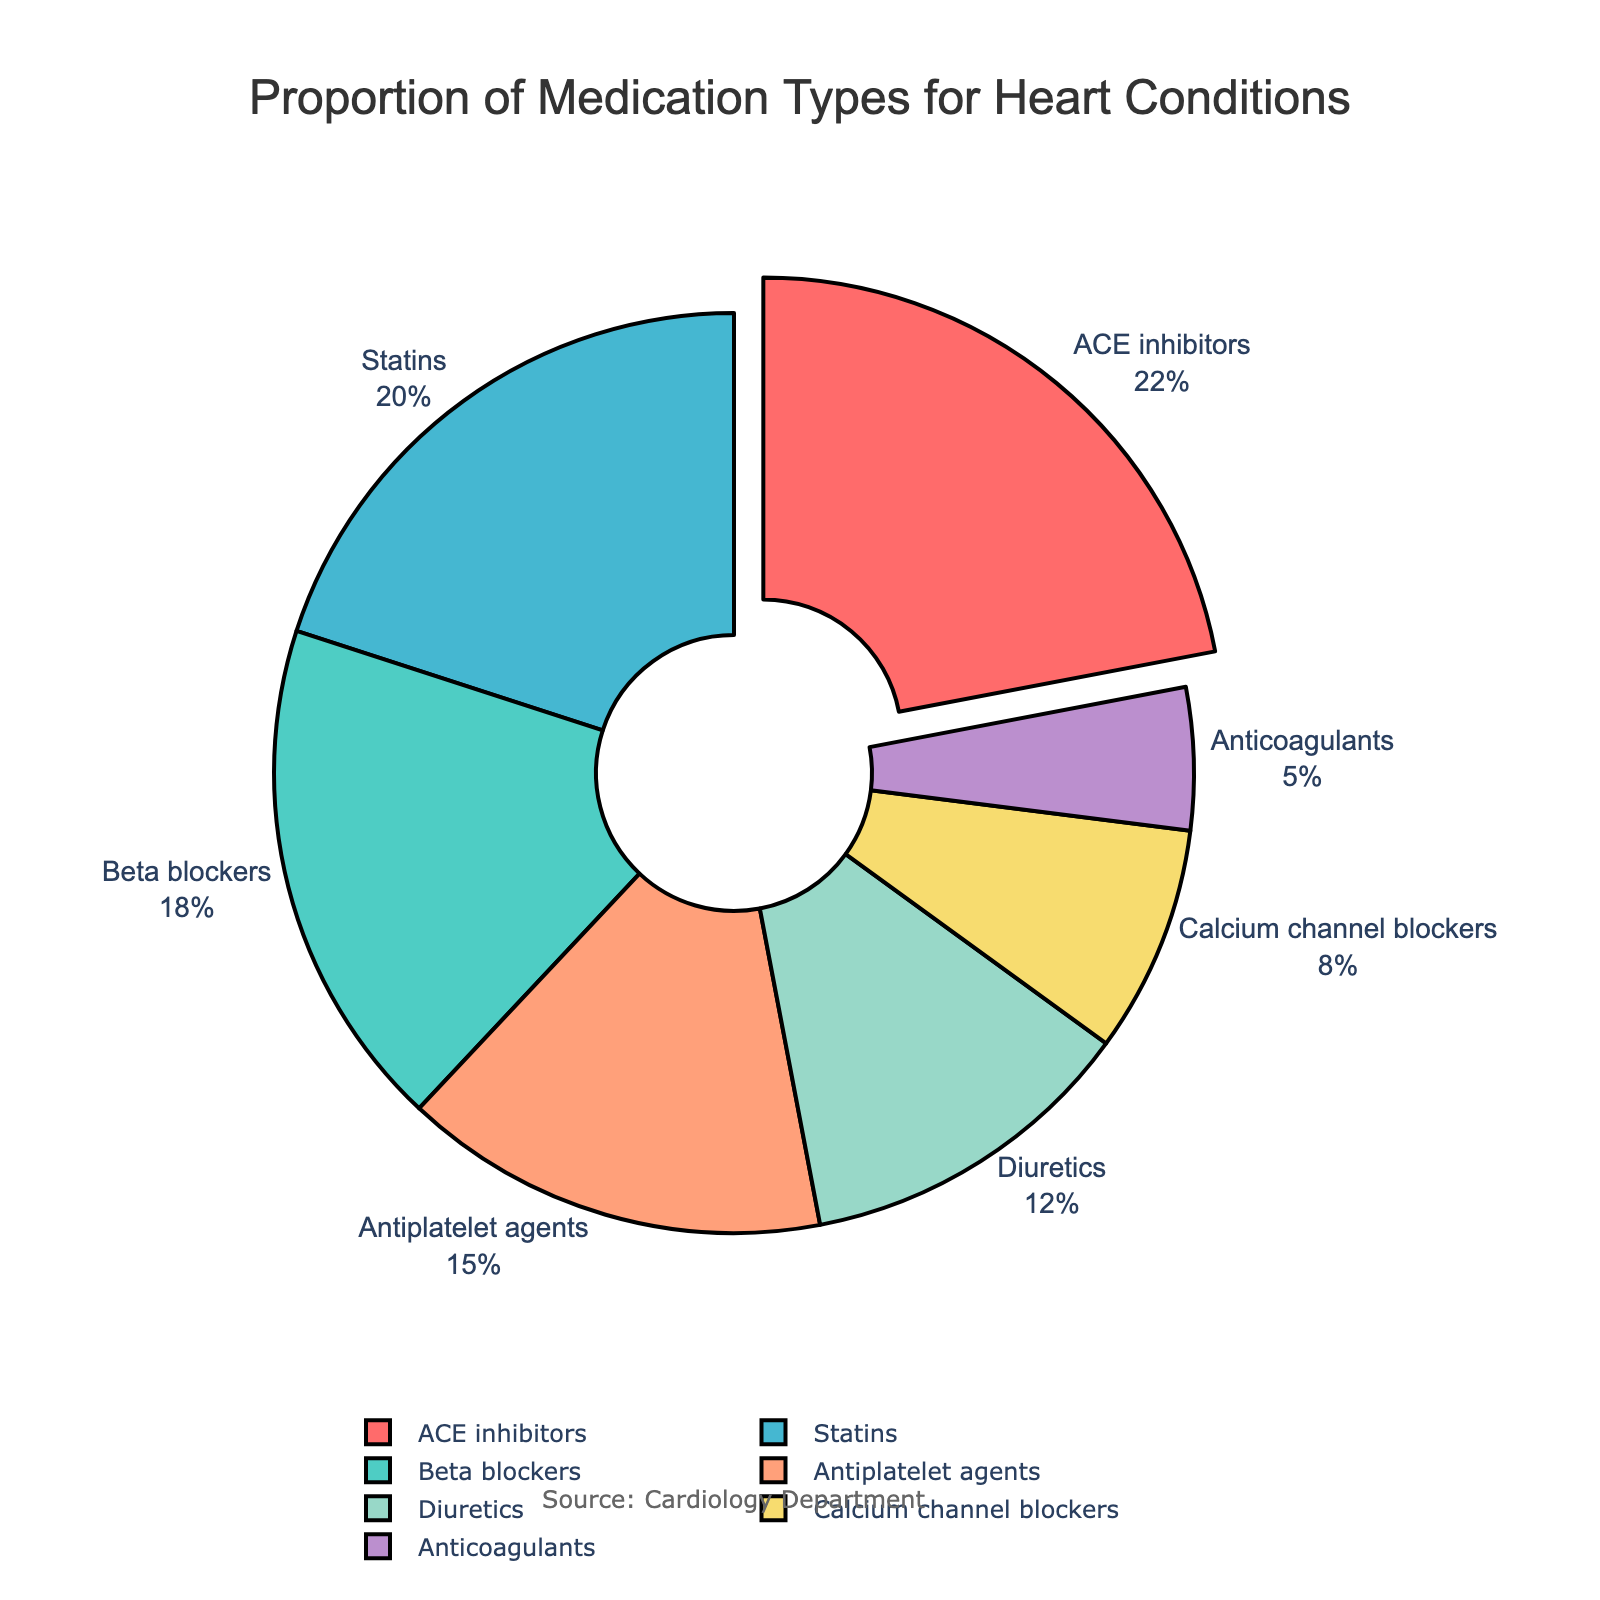What is the most frequently prescribed medication type for heart conditions according to the chart? Looking at the figure, identify the medication type with the largest percentage. This medication type also has a slice pulled out from the pie chart, indicating it is the major component. The largest segment is labeled "ACE inhibitors," which has the highest value of 22%.
Answer: ACE inhibitors What are the two least frequently prescribed medication types and their combined percentage? Identify the two medication types with the smallest percentages: "Anticoagulants" (5%) and "Calcium channel blockers" (8%). Add these percentages together: 5% + 8% = 13%.
Answer: Anticoagulants and Calcium channel blockers, 13% How much more frequently are ACE inhibitors prescribed compared to Calcium channel blockers? Identify the percentages for both ACE inhibitors (22%) and Calcium channel blockers (8%). Subtract the percentage of Calcium channel blockers from that of ACE inhibitors: 22% - 8% = 14%.
Answer: 14% What proportion of medications are prescribed as either Beta blockers or Antiplatelet agents? Identify the percentages of Beta blockers (18%) and Antiplatelet agents (15%). Add these two percentages together: 18% + 15% = 33%.
Answer: 33% Which medications constitute exactly one-third (33%) of the total prescriptions, and which colors are their slices? According to the figure, the medications Beta blockers (18%, green) and Antiplatelet agents (15%, orange) together make up 33%.
Answer: Beta blockers and Antiplatelet agents, green and orange Rank the medication types from most to least prescribed. List each medication type in order of their percentage from highest to lowest: ACE inhibitors (22%), Statins (20%), Beta blockers (18%), Antiplatelet agents (15%), Diuretics (12%), Calcium channel blockers (8%), Anticoagulants (5%).
Answer: ACE inhibitors, Statins, Beta blockers, Antiplatelet agents, Diuretics, Calcium channel blockers, Anticoagulants What color is associated with the least frequently prescribed medication type? Identify the color corresponding to the smallest slice in the chart, which is Anticoagulants (5%). The color assigned is purple.
Answer: Purple 